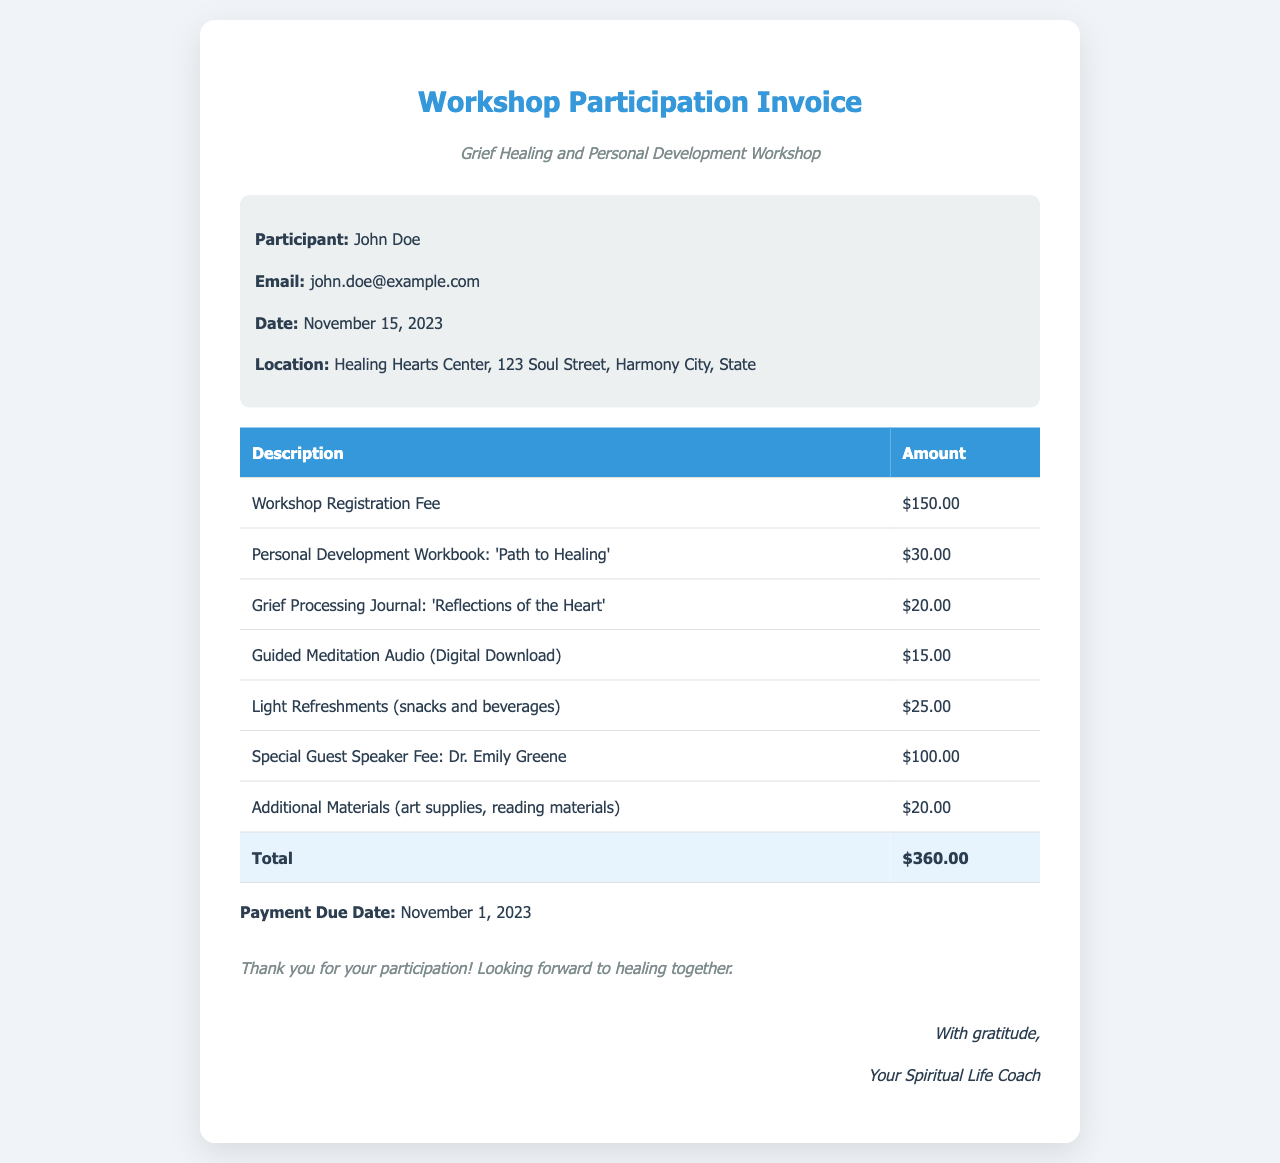What is the participant's name? The invoice states that the participant is John Doe.
Answer: John Doe What is the total amount due? The total amount due is listed as $360.00 in the total row of the invoice.
Answer: $360.00 When is the payment due? The payment due date is given in the invoice as November 1, 2023.
Answer: November 1, 2023 What is the location of the workshop? The location of the workshop is Healing Hearts Center, 123 Soul Street, Harmony City, State.
Answer: Healing Hearts Center, 123 Soul Street, Harmony City, State How much is the Workshop Registration Fee? The Workshop Registration Fee is specified as $150.00 in the itemized list.
Answer: $150.00 What is one of the materials provided for the workshop? The invoice lists several materials, one of which is the Grief Processing Journal: 'Reflections of the Heart'.
Answer: Grief Processing Journal: 'Reflections of the Heart' How many items are included in the itemized list? The invoice contains a total of 7 itemized charges listed before the total.
Answer: 7 Who is the special guest speaker? The special guest speaker mentioned in the invoice is Dr. Emily Greene.
Answer: Dr. Emily Greene What type of workshop is this invoice for? The invoice specifies that it is for a Grief Healing and Personal Development Workshop.
Answer: Grief Healing and Personal Development Workshop 